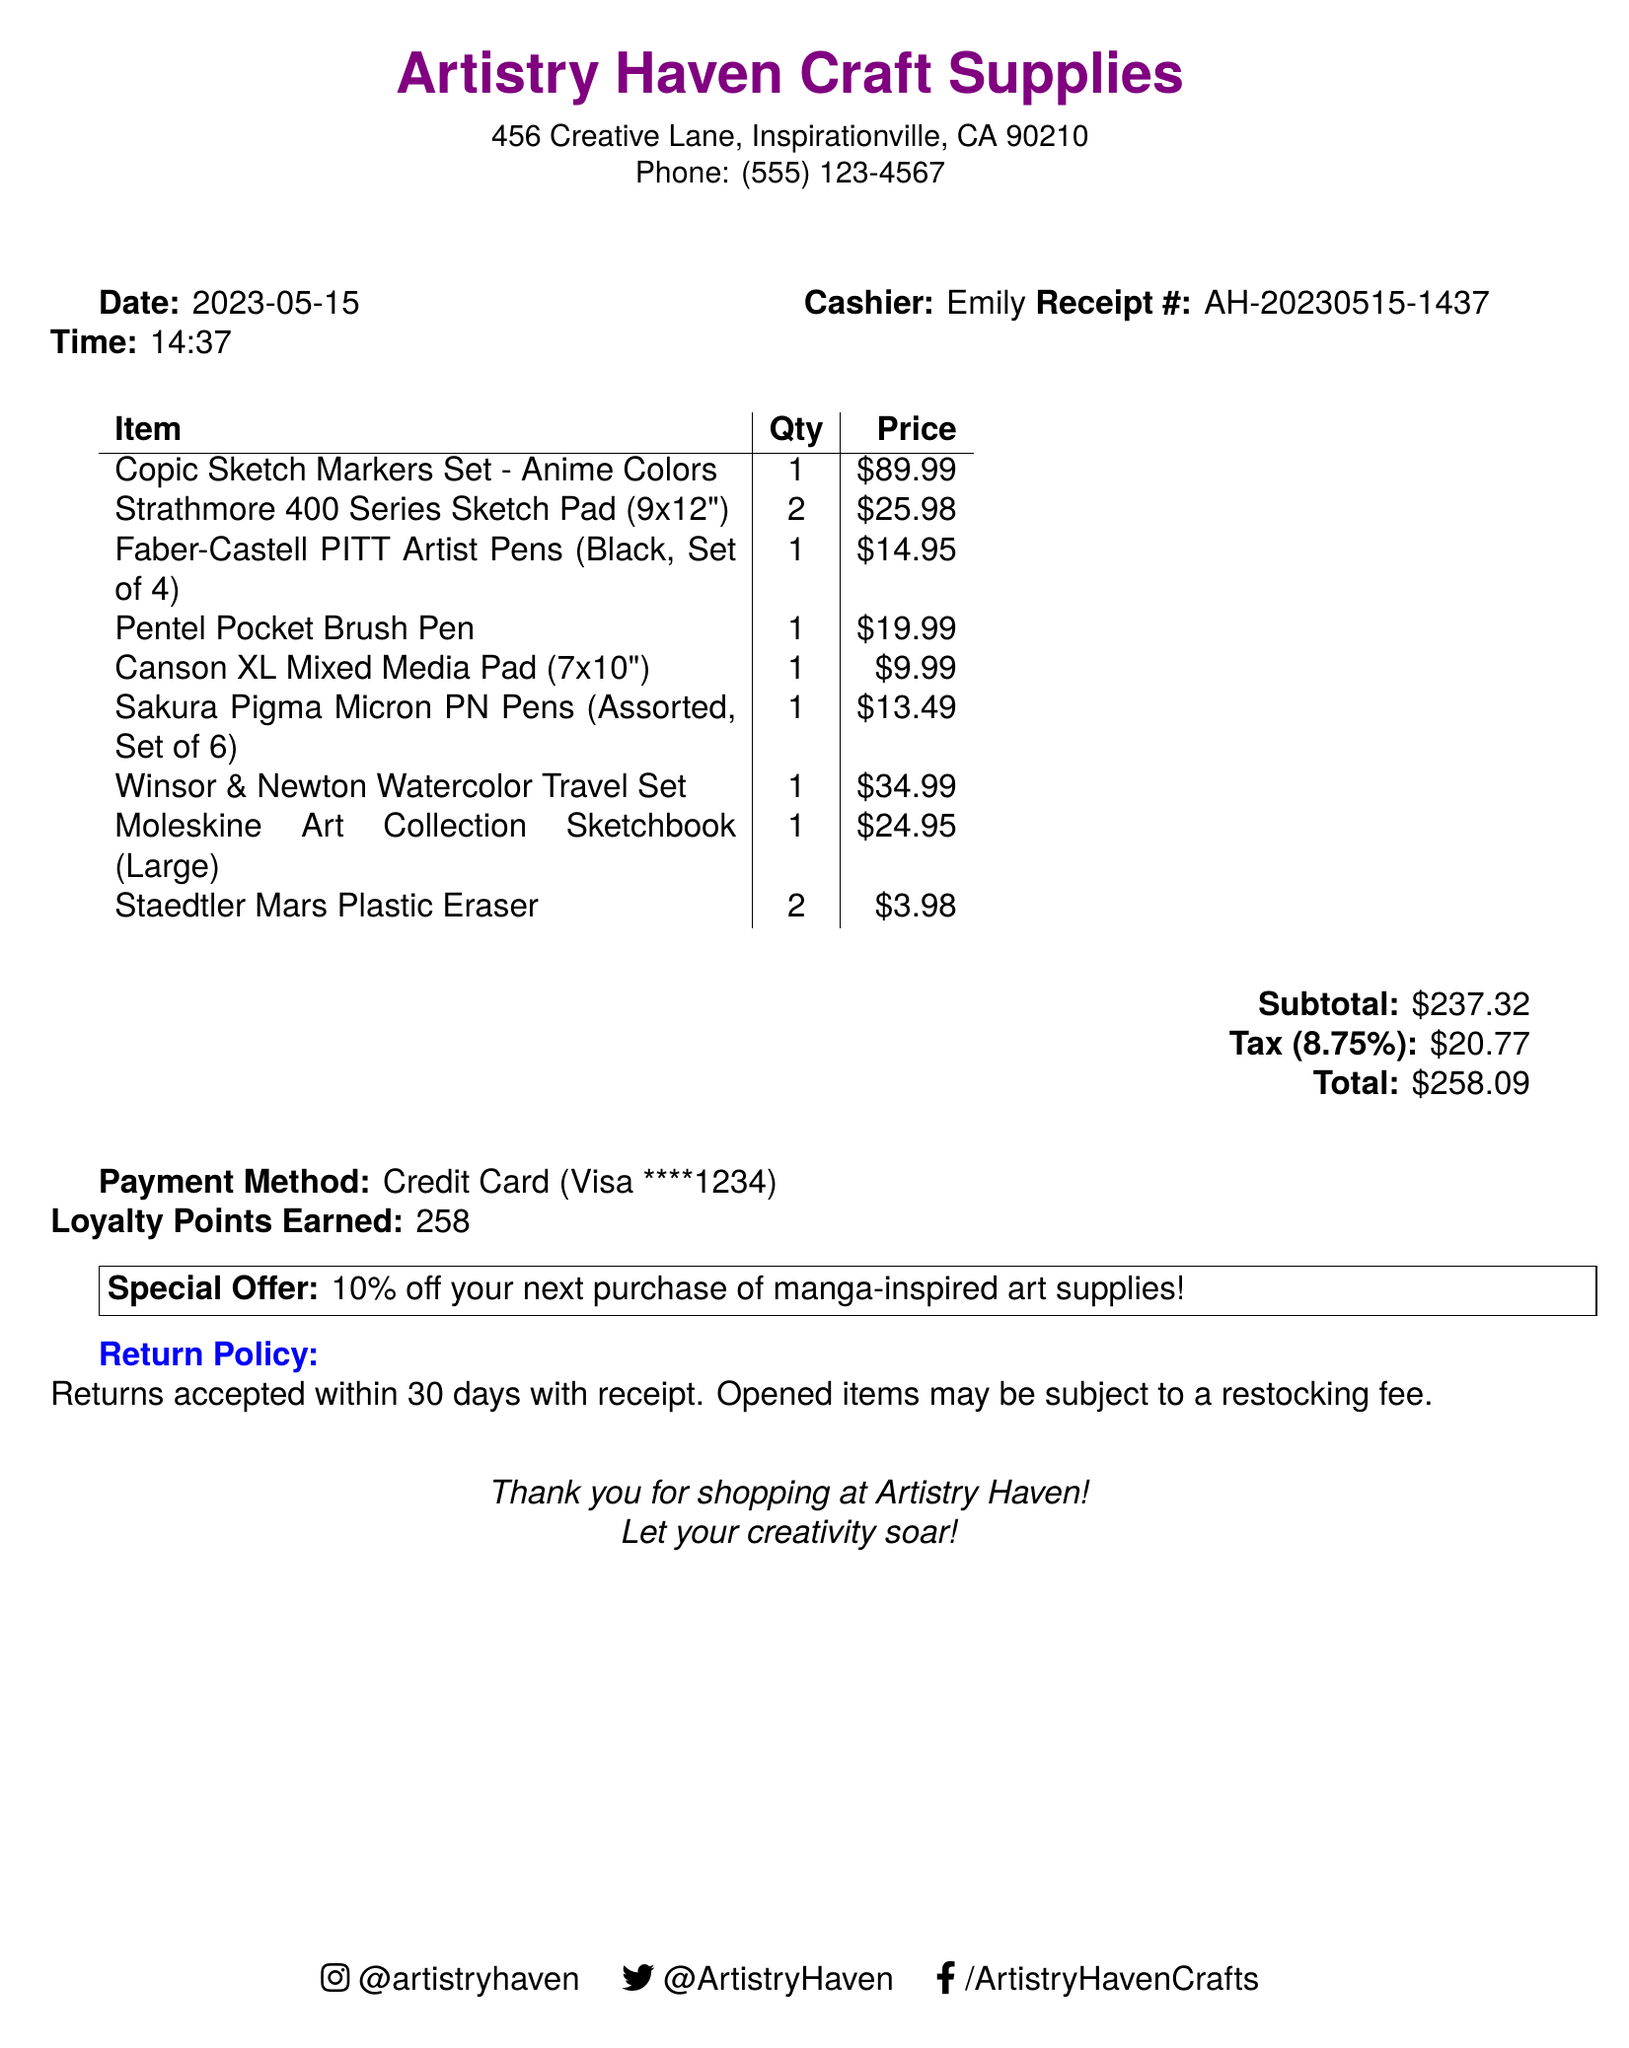What is the name of the store? The store name is located at the top of the document.
Answer: Artistry Haven Craft Supplies What is the date of the purchase? The date is specified under the date label in the document.
Answer: 2023-05-15 How many Strathmore 400 Series Sketch Pads were purchased? The quantity of Strathmore 400 Series Sketch Pads is listed in the items section.
Answer: 2 What is the tax amount? The tax amount is calculated and provided in a separate section.
Answer: $20.77 Who was the cashier during the transaction? The cashier's name is mentioned in the document near the time.
Answer: Emily What is the subtotal before tax? The subtotal is indicated in the financial summary of the document.
Answer: $237.32 How many loyalty points were earned? The loyalty points earned are clearly stated in the payment summary.
Answer: 258 What is the special offer mentioned? The special offer is highlighted in a box within the document.
Answer: 10% off your next purchase of manga-inspired art supplies! What is the payment method used? The payment method is noted in the payment section of the receipt.
Answer: Credit Card 